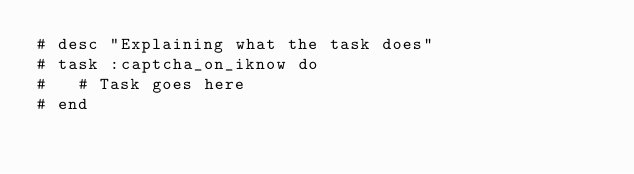<code> <loc_0><loc_0><loc_500><loc_500><_Ruby_># desc "Explaining what the task does"
# task :captcha_on_iknow do
#   # Task goes here
# end
</code> 